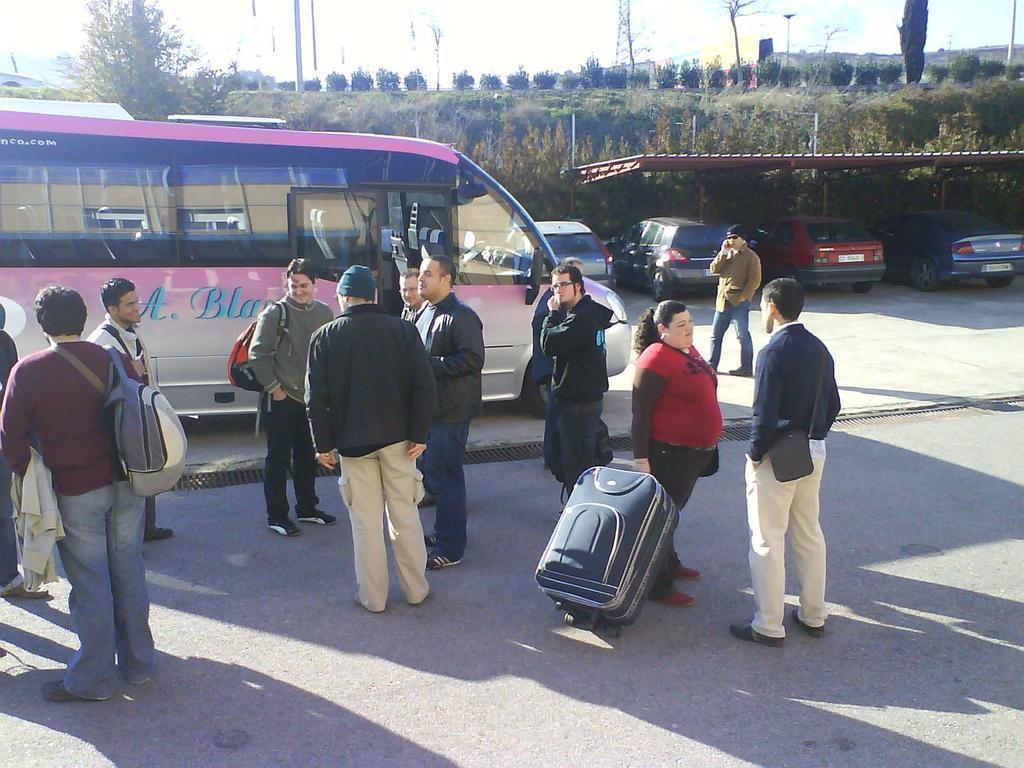Can you describe this image briefly? There are people standing and this woman holding a luggage bag and these two people wore bags and this man walking. We can see bus. In the background we can see cars parking on surface,shed,trees,plants and sky. 